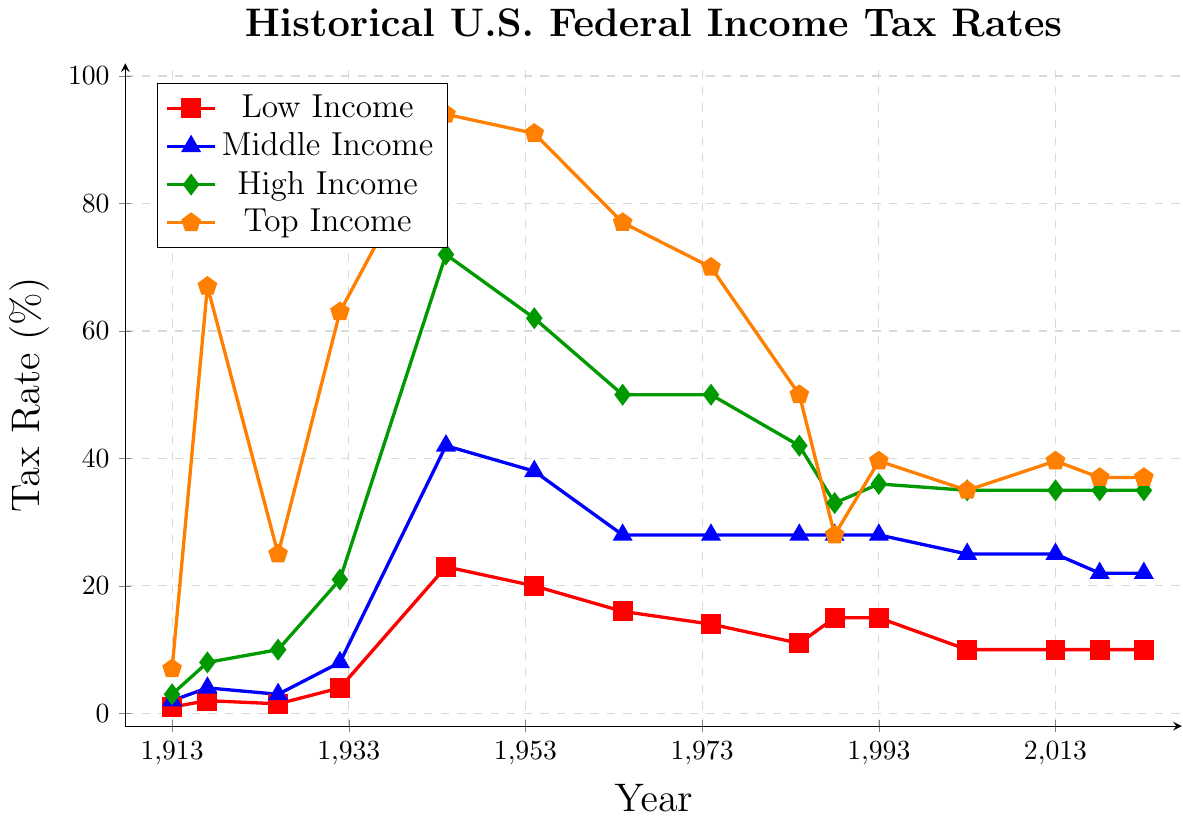What is the highest tax rate for the Top Income bracket over the years? By examining the line representing the Top Income bracket (orange line), the highest tax rate is found at the peak of this line. This peak occurs in 1944 when the tax rate is 94%.
Answer: 94% How did the tax rates for the Low Income bracket change from 1944 to 1954? Identify the values for the Low Income bracket (red line) in 1944 and 1954. The tax rate for the Low Income bracket in 1944 is 23%, and in 1954 it is 20%. Calculating the difference: 23% - 20% = 3%. Therefore, the tax rate decreased by 3%.
Answer: Decreased by 3% Which year had the largest difference between the Middle Income and the High Income tax rates? To find the year with the largest difference, examine the gap between the blue line (Middle Income) and the green line (High Income). The largest visual difference appears to be in 1944. Calculating the values: 72% (High Income) - 42% (Middle Income) = 30%.
Answer: 1944 Was there ever a year where the tax rates for High Income and Top Income were equal? Compare the green line (High Income) and the orange line (Top Income) across all years. They are equal in 1988 at a tax rate of 28%.
Answer: Yes, in 1988 What is the trend in the tax rates for the Middle Income bracket from 2003 to 2023? Trace the blue line from 2003 to 2023. The tax rate in 2003 is 25% and then it decreases to 25% in 2013 and further decreases to 22% in 2018, remaining constant until 2023.
Answer: Decreasing trend In which decade did the Low Income bracket experience the highest tax rate? Find the maximum value by evaluating the red line. The highest tax rate for the Low Income bracket is observed in the 1940s, specifically in 1944 at 23%.
Answer: 1940s How many years show an increase in the tax rate for the Low Income bracket compared to their previous year? Count the number of upward peaks in the red line when comparing consecutive years. The increases happen between: 1913-1917, 1925-1932, and 2003-2023. This results in three increases in total.
Answer: 3 years By what percentage did the tax rate for the Top Income bracket decrease from its peak in 1944 to the current rate? Identify the peak tax rate for Top Income (94% in 1944) and the current rate (37% in 2023). Compute the difference: 94% - 37% = 57%, hence the decrease is 57 percentage points.
Answer: 57% When did the tax rates for all income brackets decrease simultaneously? Observe the graph to find when all lines show a downward trend. This happens between 1944 and 1954 where all tax rates (red, blue, green, and orange) decline.
Answer: Between 1944 and 1954 What is the average tax rate of the Middle Income bracket from 1913 to 2023? Sum the tax rates for the Middle Income bracket (2%, 4%, 3%, 8%, 42%, 38%, 28%, 28%, 28%, 28%, 28%, 25%, 25%, 22%, 22%) and divide by the number of entries (15). This equals (2 + 4 + 3 + 8 + 42 + 38 + 28 + 28 + 28 + 28 + 28 + 25 + 25 + 22 + 22)/15 = 25.6%.
Answer: 25.6% 